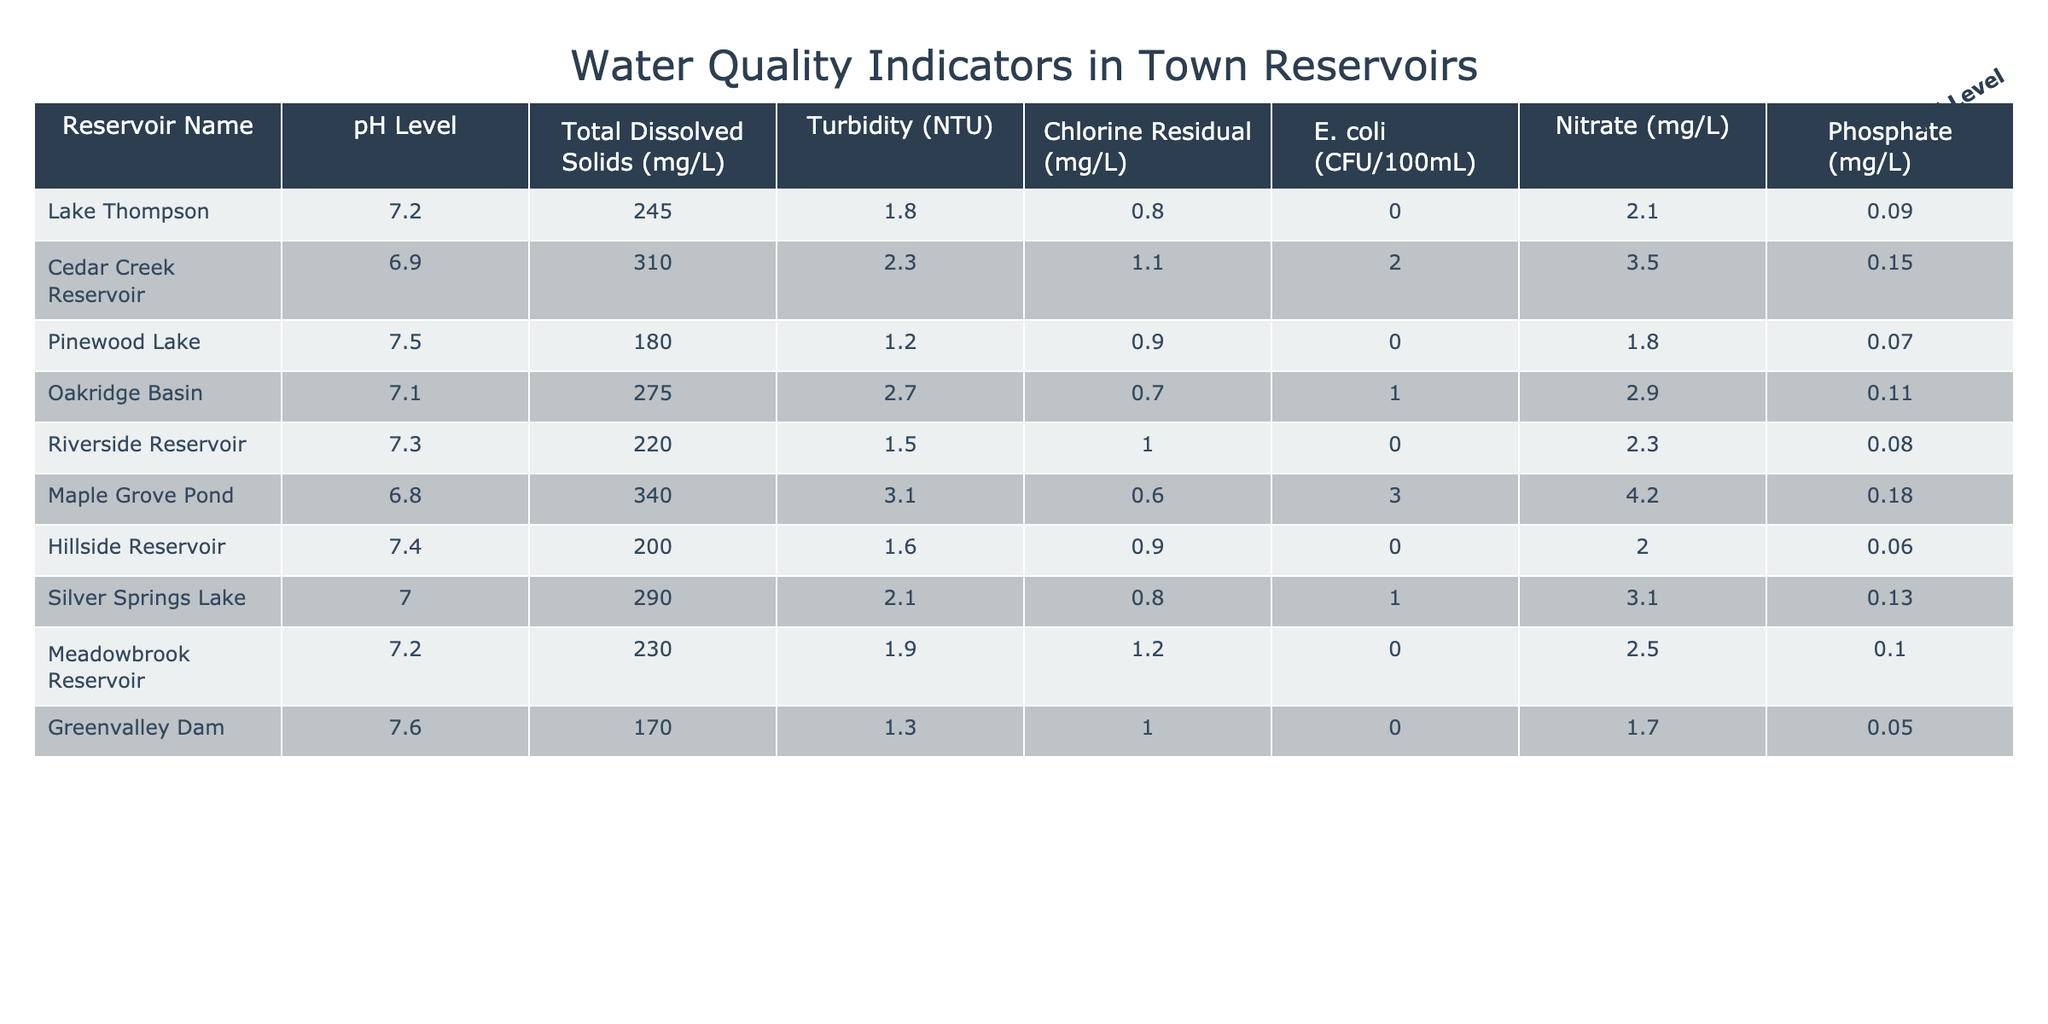What is the pH level of Cedar Creek Reservoir? The table shows a specific column for pH levels next to each reservoir name. Looking under Cedar Creek Reservoir, the pH level listed is 6.9.
Answer: 6.9 Which reservoir has the highest Total Dissolved Solids? By examining the Total Dissolved Solids column, we see that Maple Grove Pond has the highest value listed at 340 mg/L.
Answer: Maple Grove Pond What is the average Turbidity of the reservoirs? First, we sum the Turbidity values from all reservoirs: (1.8 + 2.3 + 1.2 + 2.7 + 1.5 + 3.1 + 1.6 + 2.1 + 1.9 + 1.3) = 19.5. Then, we divide by the number of reservoirs (10), resulting in an average Turbidity of 19.5 / 10 = 1.95 NTU.
Answer: 1.95 NTU Is the Chlorine Residual of Riverside Reservoir higher than 1 mg/L? Looking at the Chlorine Residual column for Riverside Reservoir, it shows a value of 1.0 mg/L, which is not higher than 1 mg/L.
Answer: No Which reservoir has the lowest Nitrate level and what is that level? The Nitrate levels for each reservoir are compared, and Pinewood Lake has the lowest value at 1.8 mg/L.
Answer: Pinewood Lake, 1.8 mg/L What is the difference in E. coli levels between Maple Grove Pond and Lake Thompson? We take the E. coli level for Maple Grove Pond, which is 3 CFU/100mL, and subtract the E. coli level for Lake Thompson, which is 0 CFU/100mL. This gives us a difference of 3 - 0 = 3 CFU/100mL.
Answer: 3 CFU/100mL Which reservoir has a higher Phosphate level, Greenvalley Dam or Hillside Reservoir? In the Phosphate column, Greenvalley Dam shows a level of 0.05 mg/L, while Hillside Reservoir shows 0.06 mg/L. Since 0.06 mg/L is greater, Hillside Reservoir has a higher Phosphate level.
Answer: Hillside Reservoir How many reservoirs have an E. coli level of 0? By reviewing the E. coli levels, we count the reservoirs: Lake Thompson, Pinewood Lake, Riverside Reservoir, and Meadowbrook Reservoir all show 0 CFU/100mL. This totals to 4 reservoirs.
Answer: 4 What is the combined Total Dissolved Solids of the top three lowest values? The three lowest Total Dissolved Solids values are from Greenvalley Dam (170 mg/L), Pinewood Lake (180 mg/L), and Hillside Reservoir (200 mg/L). Their combined value is 170 + 180 + 200 = 550 mg/L.
Answer: 550 mg/L 